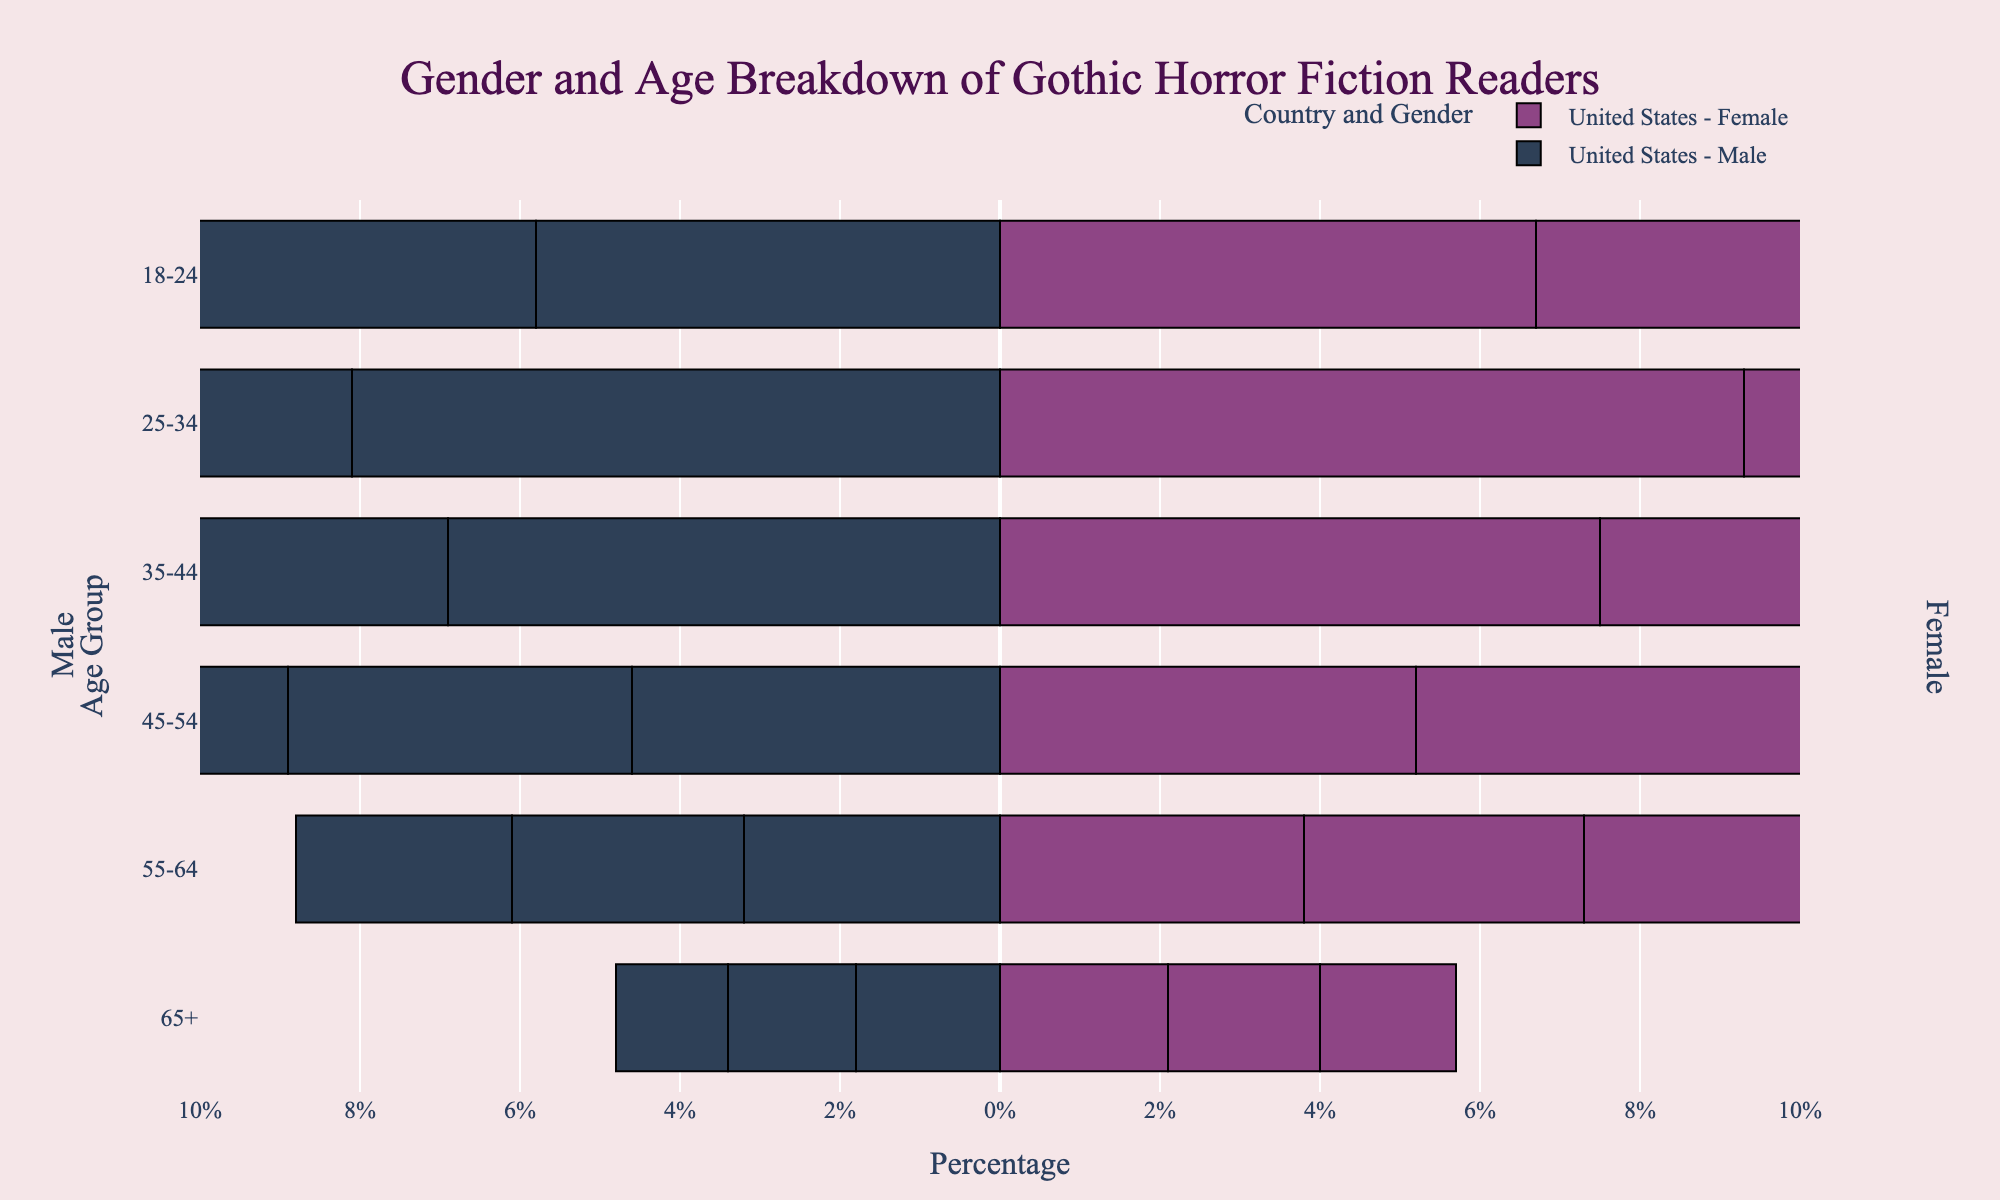What is the title of the figure? The title of the figure is placed at the top-center of the plot. It includes gothic-inspired elements and reads 'Gender and Age Breakdown of Gothic Horror Fiction Readers.'
Answer: Gender and Age Breakdown of Gothic Horror Fiction Readers Which age group has the highest percentage of female readers in the United States? Find the bar for female readers in the United States and compare the lengths. The age group '25-34' has the longest bar.
Answer: 25-34 Which country has the least percentage of male readers aged 65+? Compare the lengths of the negative bars corresponding to male readers aged 65+ across countries. Germany has the shortest bar for this group.
Answer: Germany What is the combined percentage of male and female readers aged 18-24 in the United Kingdom? Add the percentages for males and females aged 18-24 in the United Kingdom. The percentages are 5.4% for males and 6.3% for females, totaling 5.4% + 6.3% = 11.7%.
Answer: 11.7% Which age group in Germany shows the highest discrepancy between male and female readers? Look at the differences in bar lengths between male and female readers across age groups in Germany. The age group '25-34' has a discrepancy of 8.4% - 7.2% = 1.2%, which is the highest.
Answer: 25-34 Compare the percentage of female readers aged 55-64 in the United States with male readers aged 55-64 in the United Kingdom. Which group is larger and by how much? Identify the bar lengths for these groups: female readers aged 55-64 in the United States have 3.8%, and male readers aged 55-64 in the United Kingdom have 2.9%. The difference is 3.8% - 2.9% = 0.9%, favoring the United States group.
Answer: Female readers aged 55-64 in the United States by 0.9% How does the percentage of male readers aged 45-54 in Germany compare to female readers aged 45-54 in the same country? Observe the bars representing male and female readers aged 45-54 in Germany. The percentage for males is 4.0%, and for females, it is 4.6%. Since 4.6% > 4.0%, there are more female readers in this age group.
Answer: Female readers are higher by 0.6% What is the total percentage of male readers aged 35-44 across all countries? Sum the percentages of male readers aged 35-44 for each country: United States (6.9%), United Kingdom (6.5%), and Germany (6.2%). Total = 6.9% + 6.5% + 6.2% = 19.6%.
Answer: 19.6% 